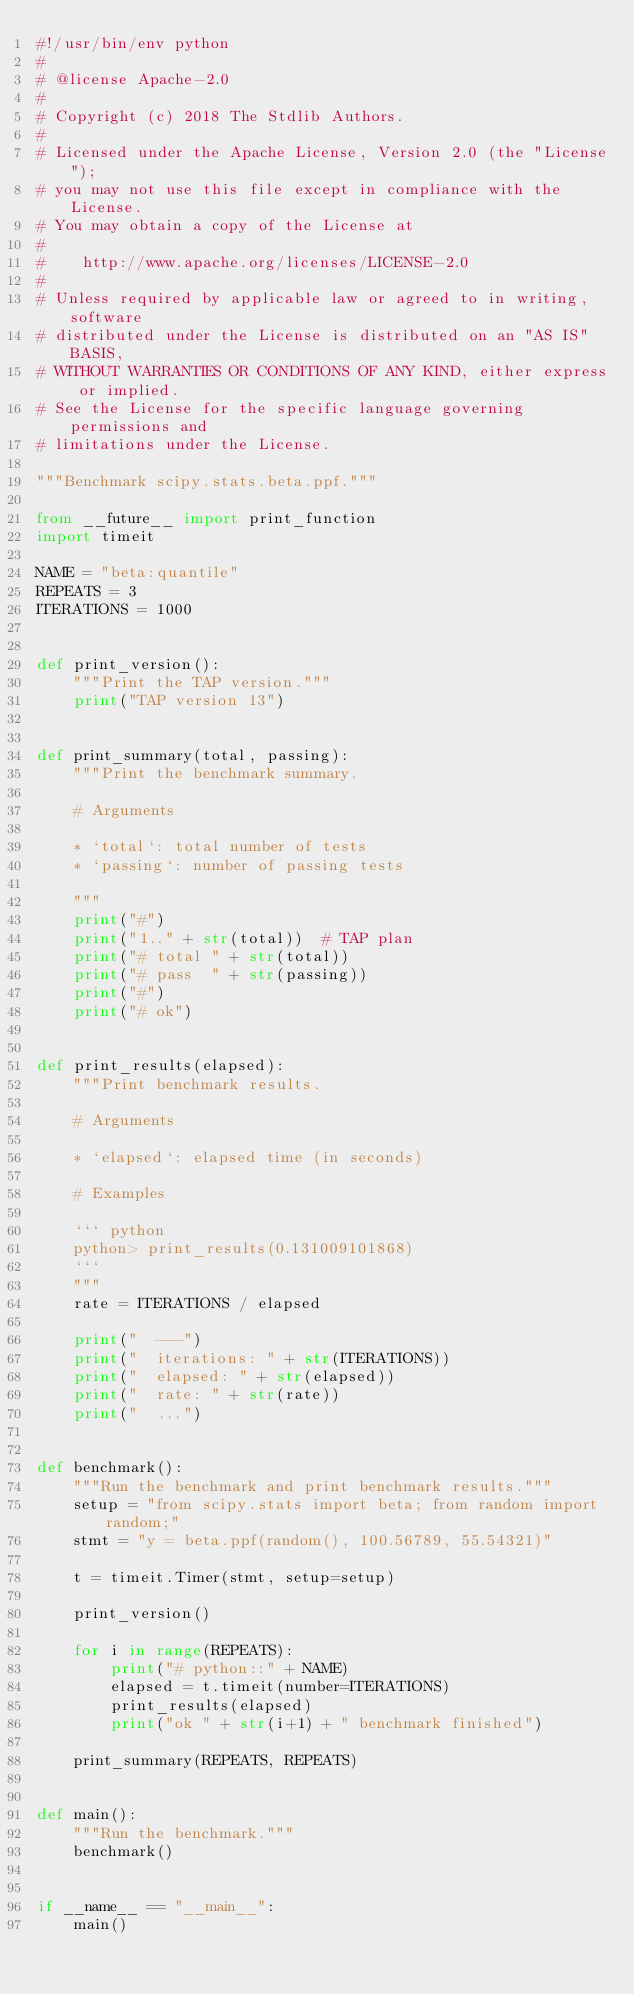Convert code to text. <code><loc_0><loc_0><loc_500><loc_500><_Python_>#!/usr/bin/env python
#
# @license Apache-2.0
#
# Copyright (c) 2018 The Stdlib Authors.
#
# Licensed under the Apache License, Version 2.0 (the "License");
# you may not use this file except in compliance with the License.
# You may obtain a copy of the License at
#
#    http://www.apache.org/licenses/LICENSE-2.0
#
# Unless required by applicable law or agreed to in writing, software
# distributed under the License is distributed on an "AS IS" BASIS,
# WITHOUT WARRANTIES OR CONDITIONS OF ANY KIND, either express or implied.
# See the License for the specific language governing permissions and
# limitations under the License.

"""Benchmark scipy.stats.beta.ppf."""

from __future__ import print_function
import timeit

NAME = "beta:quantile"
REPEATS = 3
ITERATIONS = 1000


def print_version():
    """Print the TAP version."""
    print("TAP version 13")


def print_summary(total, passing):
    """Print the benchmark summary.

    # Arguments

    * `total`: total number of tests
    * `passing`: number of passing tests

    """
    print("#")
    print("1.." + str(total))  # TAP plan
    print("# total " + str(total))
    print("# pass  " + str(passing))
    print("#")
    print("# ok")


def print_results(elapsed):
    """Print benchmark results.

    # Arguments

    * `elapsed`: elapsed time (in seconds)

    # Examples

    ``` python
    python> print_results(0.131009101868)
    ```
    """
    rate = ITERATIONS / elapsed

    print("  ---")
    print("  iterations: " + str(ITERATIONS))
    print("  elapsed: " + str(elapsed))
    print("  rate: " + str(rate))
    print("  ...")


def benchmark():
    """Run the benchmark and print benchmark results."""
    setup = "from scipy.stats import beta; from random import random;"
    stmt = "y = beta.ppf(random(), 100.56789, 55.54321)"

    t = timeit.Timer(stmt, setup=setup)

    print_version()

    for i in range(REPEATS):
        print("# python::" + NAME)
        elapsed = t.timeit(number=ITERATIONS)
        print_results(elapsed)
        print("ok " + str(i+1) + " benchmark finished")

    print_summary(REPEATS, REPEATS)


def main():
    """Run the benchmark."""
    benchmark()


if __name__ == "__main__":
    main()
</code> 